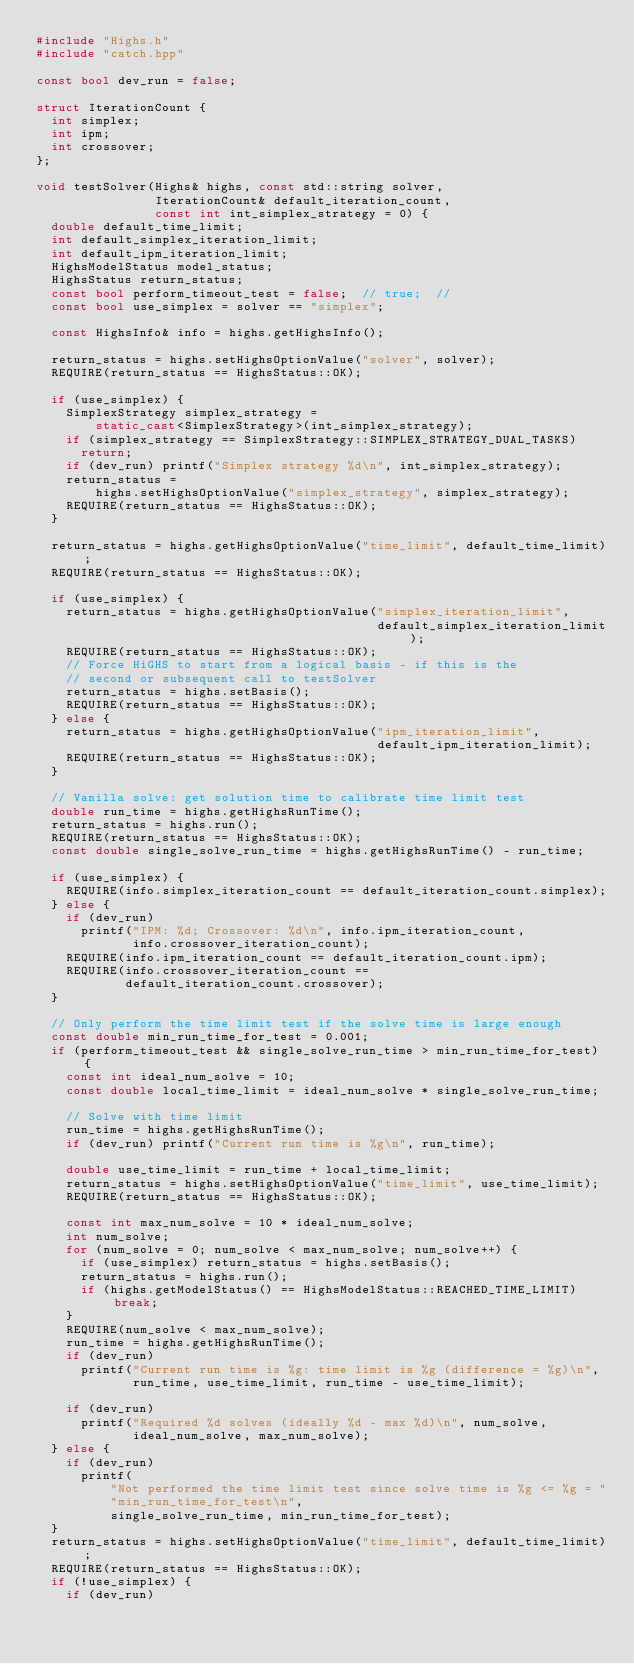Convert code to text. <code><loc_0><loc_0><loc_500><loc_500><_C++_>#include "Highs.h"
#include "catch.hpp"

const bool dev_run = false;

struct IterationCount {
  int simplex;
  int ipm;
  int crossover;
};

void testSolver(Highs& highs, const std::string solver,
                IterationCount& default_iteration_count,
                const int int_simplex_strategy = 0) {
  double default_time_limit;
  int default_simplex_iteration_limit;
  int default_ipm_iteration_limit;
  HighsModelStatus model_status;
  HighsStatus return_status;
  const bool perform_timeout_test = false;  // true;  //
  const bool use_simplex = solver == "simplex";

  const HighsInfo& info = highs.getHighsInfo();

  return_status = highs.setHighsOptionValue("solver", solver);
  REQUIRE(return_status == HighsStatus::OK);

  if (use_simplex) {
    SimplexStrategy simplex_strategy =
        static_cast<SimplexStrategy>(int_simplex_strategy);
    if (simplex_strategy == SimplexStrategy::SIMPLEX_STRATEGY_DUAL_TASKS)
      return;
    if (dev_run) printf("Simplex strategy %d\n", int_simplex_strategy);
    return_status =
        highs.setHighsOptionValue("simplex_strategy", simplex_strategy);
    REQUIRE(return_status == HighsStatus::OK);
  }

  return_status = highs.getHighsOptionValue("time_limit", default_time_limit);
  REQUIRE(return_status == HighsStatus::OK);

  if (use_simplex) {
    return_status = highs.getHighsOptionValue("simplex_iteration_limit",
                                              default_simplex_iteration_limit);
    REQUIRE(return_status == HighsStatus::OK);
    // Force HiGHS to start from a logical basis - if this is the
    // second or subsequent call to testSolver
    return_status = highs.setBasis();
    REQUIRE(return_status == HighsStatus::OK);
  } else {
    return_status = highs.getHighsOptionValue("ipm_iteration_limit",
                                              default_ipm_iteration_limit);
    REQUIRE(return_status == HighsStatus::OK);
  }

  // Vanilla solve: get solution time to calibrate time limit test
  double run_time = highs.getHighsRunTime();
  return_status = highs.run();
  REQUIRE(return_status == HighsStatus::OK);
  const double single_solve_run_time = highs.getHighsRunTime() - run_time;

  if (use_simplex) {
    REQUIRE(info.simplex_iteration_count == default_iteration_count.simplex);
  } else {
    if (dev_run)
      printf("IPM: %d; Crossover: %d\n", info.ipm_iteration_count,
             info.crossover_iteration_count);
    REQUIRE(info.ipm_iteration_count == default_iteration_count.ipm);
    REQUIRE(info.crossover_iteration_count ==
            default_iteration_count.crossover);
  }

  // Only perform the time limit test if the solve time is large enough
  const double min_run_time_for_test = 0.001;
  if (perform_timeout_test && single_solve_run_time > min_run_time_for_test) {
    const int ideal_num_solve = 10;
    const double local_time_limit = ideal_num_solve * single_solve_run_time;

    // Solve with time limit
    run_time = highs.getHighsRunTime();
    if (dev_run) printf("Current run time is %g\n", run_time);

    double use_time_limit = run_time + local_time_limit;
    return_status = highs.setHighsOptionValue("time_limit", use_time_limit);
    REQUIRE(return_status == HighsStatus::OK);

    const int max_num_solve = 10 * ideal_num_solve;
    int num_solve;
    for (num_solve = 0; num_solve < max_num_solve; num_solve++) {
      if (use_simplex) return_status = highs.setBasis();
      return_status = highs.run();
      if (highs.getModelStatus() == HighsModelStatus::REACHED_TIME_LIMIT) break;
    }
    REQUIRE(num_solve < max_num_solve);
    run_time = highs.getHighsRunTime();
    if (dev_run)
      printf("Current run time is %g: time limit is %g (difference = %g)\n",
             run_time, use_time_limit, run_time - use_time_limit);

    if (dev_run)
      printf("Required %d solves (ideally %d - max %d)\n", num_solve,
             ideal_num_solve, max_num_solve);
  } else {
    if (dev_run)
      printf(
          "Not performed the time limit test since solve time is %g <= %g = "
          "min_run_time_for_test\n",
          single_solve_run_time, min_run_time_for_test);
  }
  return_status = highs.setHighsOptionValue("time_limit", default_time_limit);
  REQUIRE(return_status == HighsStatus::OK);
  if (!use_simplex) {
    if (dev_run)</code> 